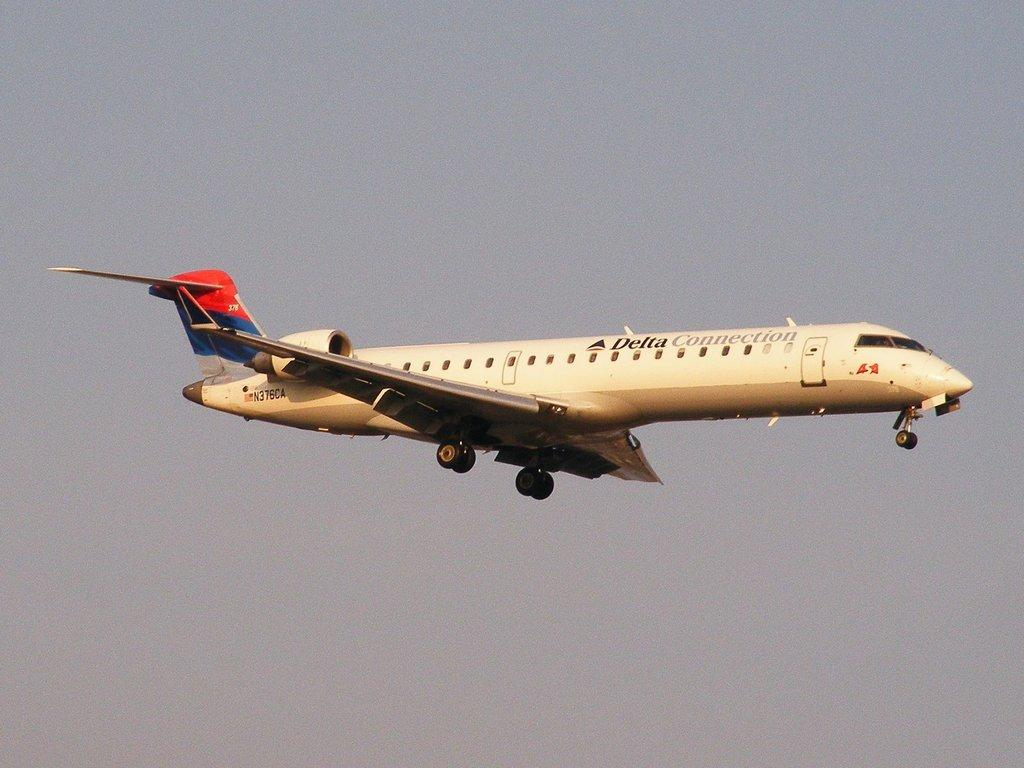Provide a one-sentence caption for the provided image. Delta plane N376CA flies through the sky and its landing gear is down. 